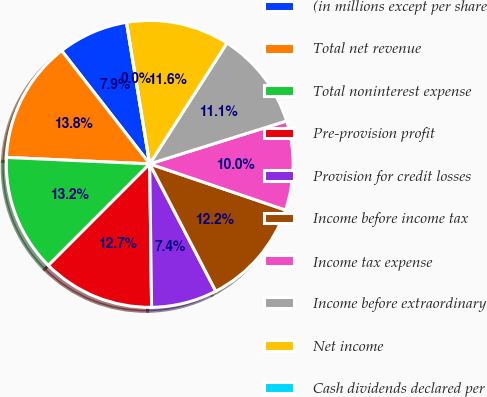<chart> <loc_0><loc_0><loc_500><loc_500><pie_chart><fcel>(in millions except per share<fcel>Total net revenue<fcel>Total noninterest expense<fcel>Pre-provision profit<fcel>Provision for credit losses<fcel>Income before income tax<fcel>Income tax expense<fcel>Income before extraordinary<fcel>Net income<fcel>Cash dividends declared per<nl><fcel>7.94%<fcel>13.76%<fcel>13.23%<fcel>12.7%<fcel>7.41%<fcel>12.17%<fcel>10.05%<fcel>11.11%<fcel>11.64%<fcel>0.0%<nl></chart> 